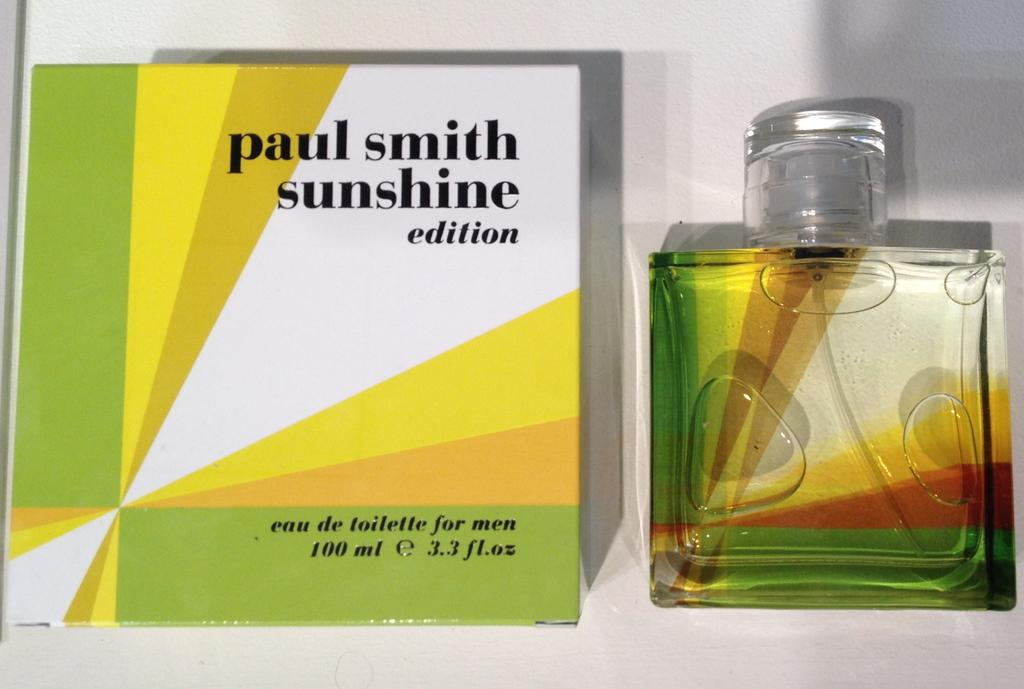<image>
Create a compact narrative representing the image presented. Bottle of cologne next to a box that says Paul Smith Sunshine. 